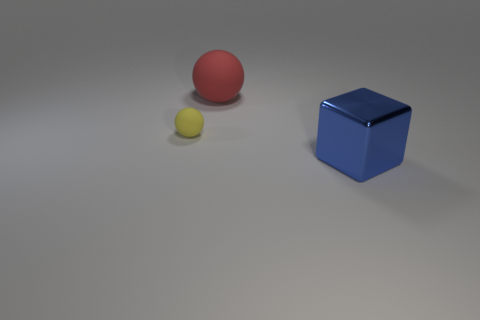Subtract all red spheres. How many spheres are left? 1 Add 2 big blue metallic things. How many objects exist? 5 Subtract all blocks. How many objects are left? 2 Subtract all purple blocks. How many yellow spheres are left? 1 Subtract all small red rubber things. Subtract all large matte things. How many objects are left? 2 Add 1 large red objects. How many large red objects are left? 2 Add 1 big cylinders. How many big cylinders exist? 1 Subtract 0 gray balls. How many objects are left? 3 Subtract 2 balls. How many balls are left? 0 Subtract all cyan blocks. Subtract all gray cylinders. How many blocks are left? 1 